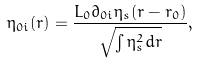<formula> <loc_0><loc_0><loc_500><loc_500>\eta _ { 0 i } ( { r } ) = \frac { L _ { 0 } \partial _ { 0 i } \eta _ { s } ( { r } - { r } _ { 0 } ) } { \sqrt { \int \eta _ { s } ^ { 2 } d { r } } } ,</formula> 